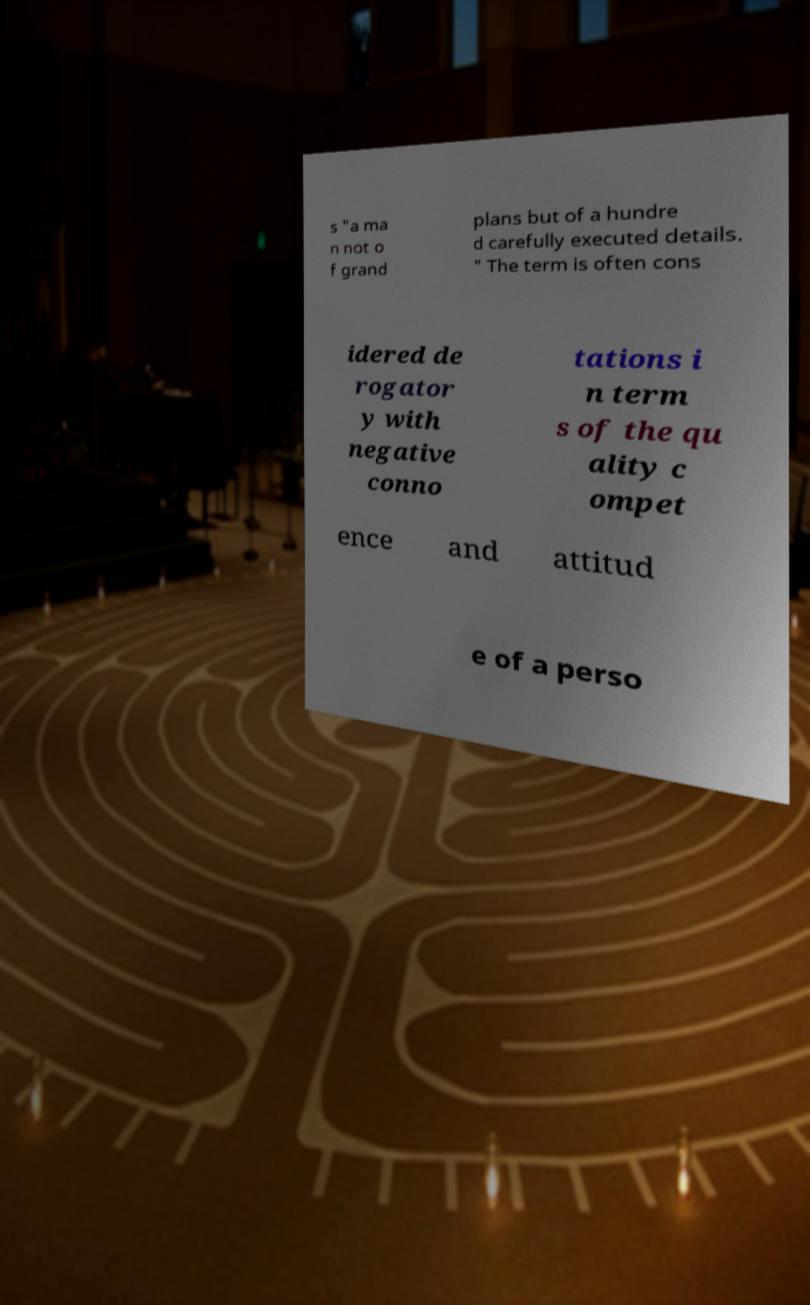For documentation purposes, I need the text within this image transcribed. Could you provide that? s "a ma n not o f grand plans but of a hundre d carefully executed details. " The term is often cons idered de rogator y with negative conno tations i n term s of the qu ality c ompet ence and attitud e of a perso 